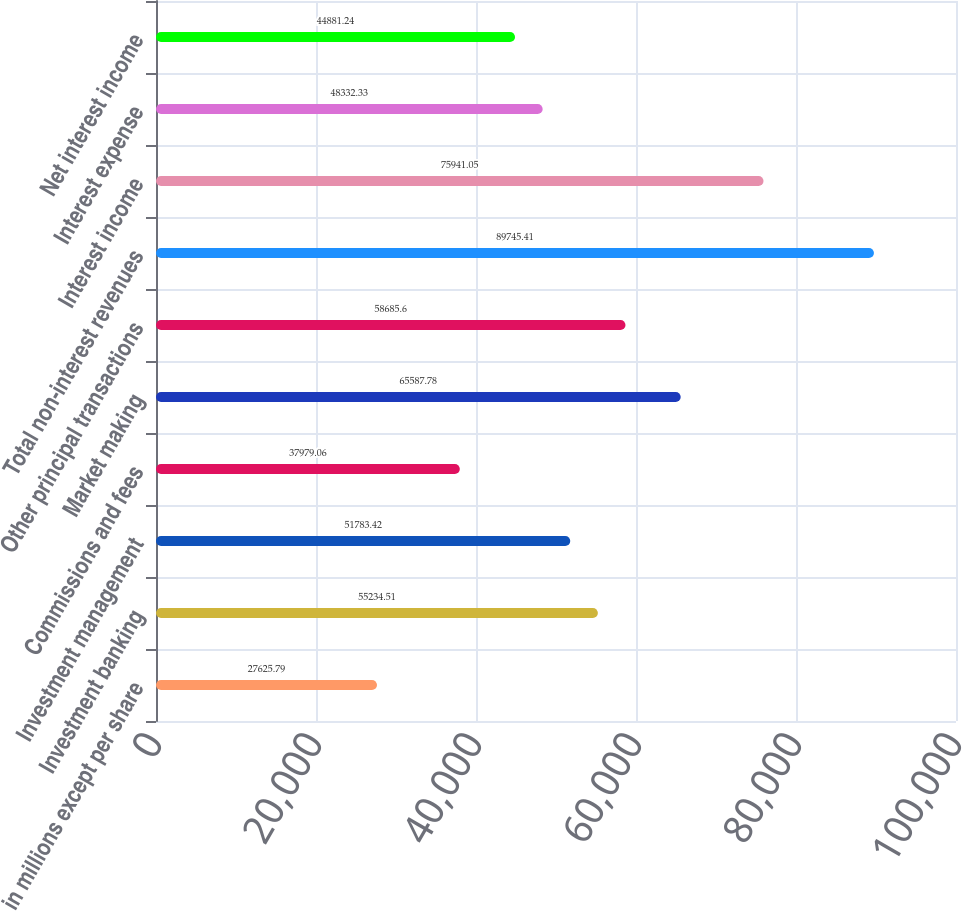Convert chart to OTSL. <chart><loc_0><loc_0><loc_500><loc_500><bar_chart><fcel>in millions except per share<fcel>Investment banking<fcel>Investment management<fcel>Commissions and fees<fcel>Market making<fcel>Other principal transactions<fcel>Total non-interest revenues<fcel>Interest income<fcel>Interest expense<fcel>Net interest income<nl><fcel>27625.8<fcel>55234.5<fcel>51783.4<fcel>37979.1<fcel>65587.8<fcel>58685.6<fcel>89745.4<fcel>75941.1<fcel>48332.3<fcel>44881.2<nl></chart> 